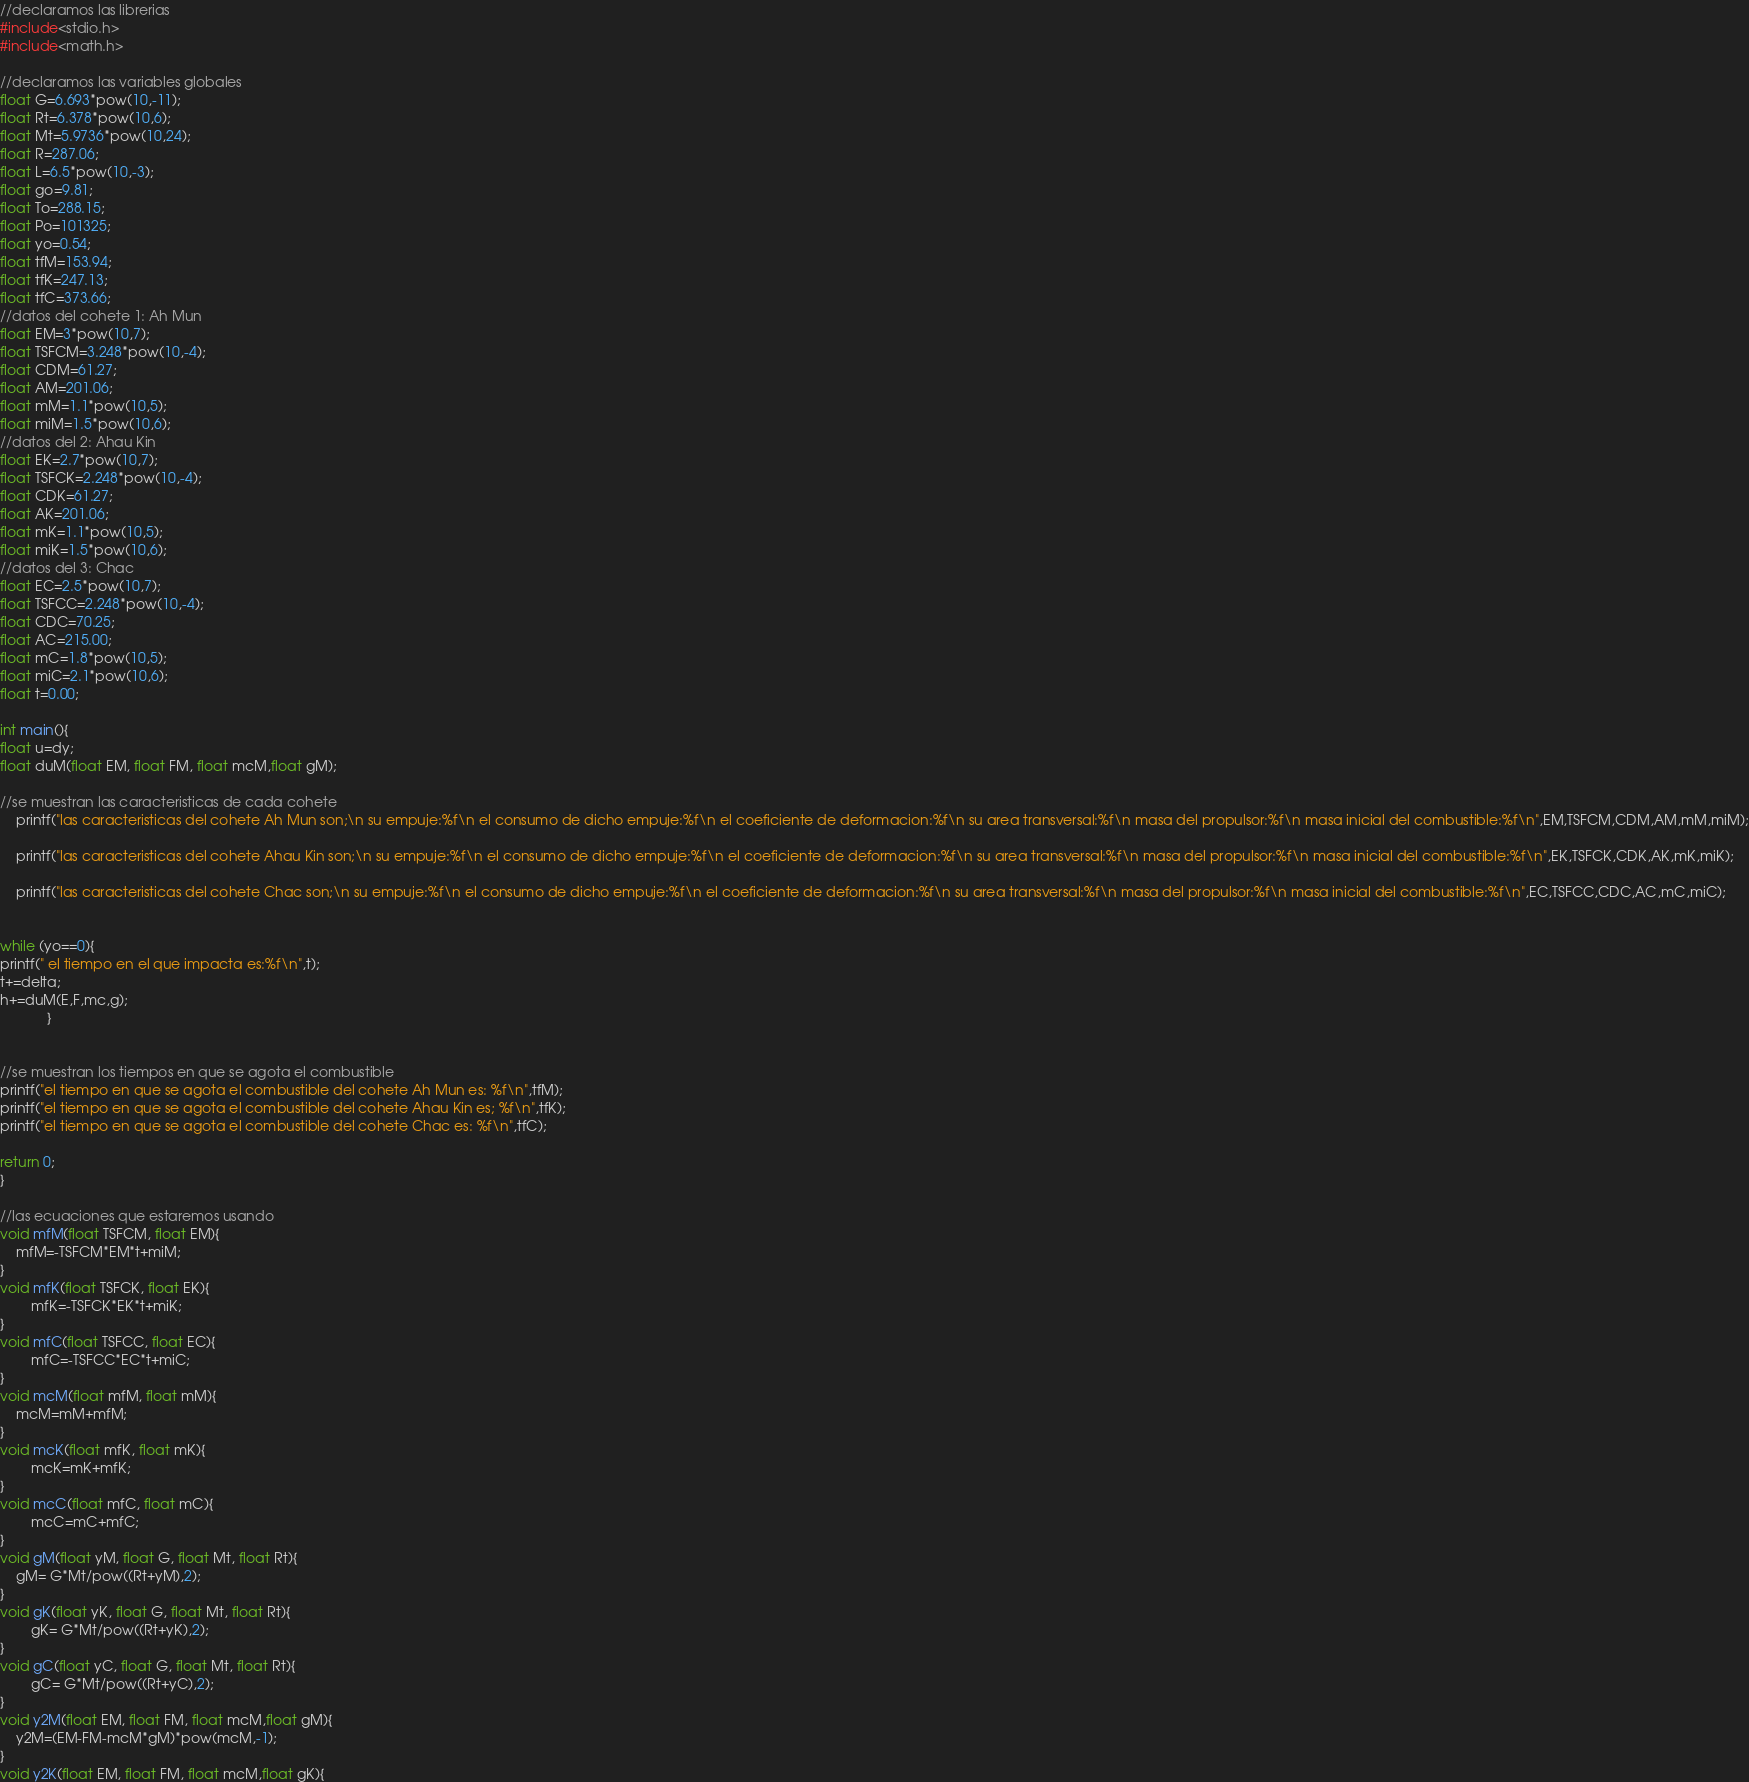<code> <loc_0><loc_0><loc_500><loc_500><_C_>//declaramos las librerias
#include<stdio.h>
#include<math.h>

//declaramos las variables globales
float G=6.693*pow(10,-11);
float Rt=6.378*pow(10,6);
float Mt=5.9736*pow(10,24);
float R=287.06;
float L=6.5*pow(10,-3);
float go=9.81;
float To=288.15;
float Po=101325;
float yo=0.54;
float tfM=153.94;
float tfK=247.13;
float tfC=373.66;
//datos del cohete 1: Ah Mun
float EM=3*pow(10,7);
float TSFCM=3.248*pow(10,-4);
float CDM=61.27;
float AM=201.06;
float mM=1.1*pow(10,5);
float miM=1.5*pow(10,6);
//datos del 2: Ahau Kin
float EK=2.7*pow(10,7);
float TSFCK=2.248*pow(10,-4);
float CDK=61.27;
float AK=201.06;
float mK=1.1*pow(10,5);
float miK=1.5*pow(10,6);
//datos del 3: Chac
float EC=2.5*pow(10,7);
float TSFCC=2.248*pow(10,-4);
float CDC=70.25;
float AC=215.00;
float mC=1.8*pow(10,5);
float miC=2.1*pow(10,6);
float t=0.00;

int main(){
float u=dy;
float duM(float EM, float FM, float mcM,float gM);

//se muestran las caracteristicas de cada cohete
	printf("las caracteristicas del cohete Ah Mun son;\n su empuje:%f\n el consumo de dicho empuje:%f\n el coeficiente de deformacion:%f\n su area transversal:%f\n masa del propulsor:%f\n masa inicial del combustible:%f\n",EM,TSFCM,CDM,AM,mM,miM);

	printf("las caracteristicas del cohete Ahau Kin son;\n su empuje:%f\n el consumo de dicho empuje:%f\n el coeficiente de deformacion:%f\n su area transversal:%f\n masa del propulsor:%f\n masa inicial del combustible:%f\n",EK,TSFCK,CDK,AK,mK,miK);

	printf("las caracteristicas del cohete Chac son;\n su empuje:%f\n el consumo de dicho empuje:%f\n el coeficiente de deformacion:%f\n su area transversal:%f\n masa del propulsor:%f\n masa inicial del combustible:%f\n",EC,TSFCC,CDC,AC,mC,miC);


while (yo==0){
printf(" el tiempo en el que impacta es:%f\n",t);
t+=delta;
h+=duM(E,F,mc,g);
			}


//se muestran los tiempos en que se agota el combustible
printf("el tiempo en que se agota el combustible del cohete Ah Mun es: %f\n",tfM);
printf("el tiempo en que se agota el combustible del cohete Ahau Kin es; %f\n",tfK);
printf("el tiempo en que se agota el combustible del cohete Chac es: %f\n",tfC);

return 0;
}

//las ecuaciones que estaremos usando
void mfM(float TSFCM, float EM){
	mfM=-TSFCM*EM*t+miM;
}
void mfK(float TSFCK, float EK){
        mfK=-TSFCK*EK*t+miK;
}
void mfC(float TSFCC, float EC){
        mfC=-TSFCC*EC*t+miC;
}
void mcM(float mfM, float mM){
	mcM=mM+mfM;
}
void mcK(float mfK, float mK){
        mcK=mK+mfK;
}
void mcC(float mfC, float mC){
        mcC=mC+mfC;
}
void gM(float yM, float G, float Mt, float Rt){
	gM= G*Mt/pow((Rt+yM),2);
}
void gK(float yK, float G, float Mt, float Rt){
        gK= G*Mt/pow((Rt+yK),2);
}
void gC(float yC, float G, float Mt, float Rt){
        gC= G*Mt/pow((Rt+yC),2);
}
void y2M(float EM, float FM, float mcM,float gM){
	y2M=(EM-FM-mcM*gM)*pow(mcM,-1);
}
void y2K(float EM, float FM, float mcM,float gK){</code> 